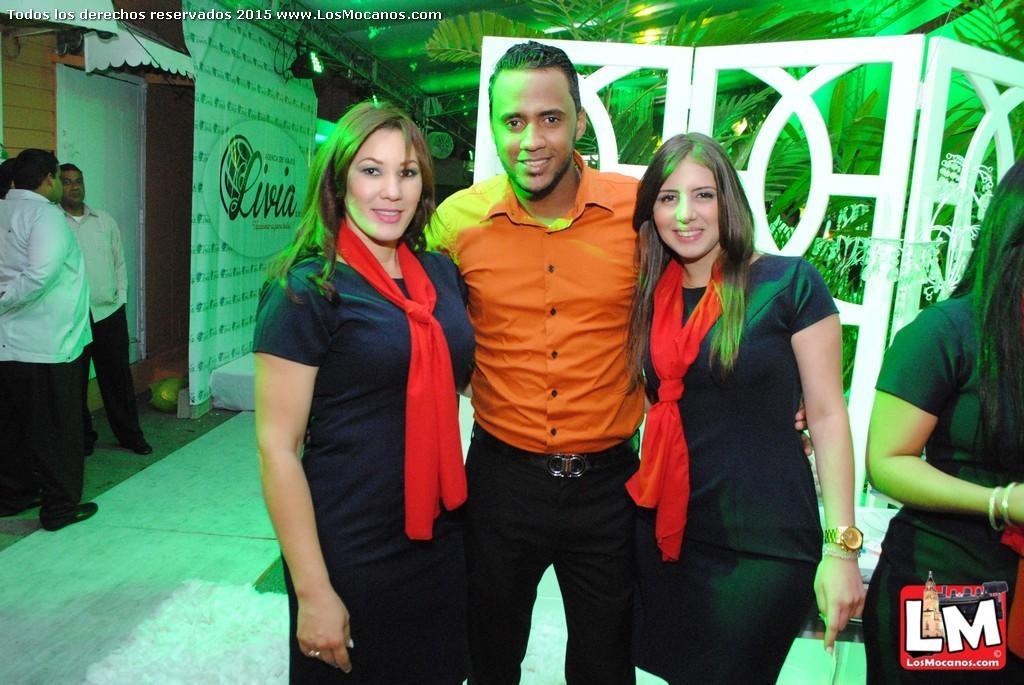Please provide a concise description of this image. In this picture we can see a man wearing an orange shirt standing in the front, smiling and giving a pose to the camera. On both sides we can see two women wearing a black dress and giving a pose. In the background there is a white partition board. On the left corner we can see a white banner.  